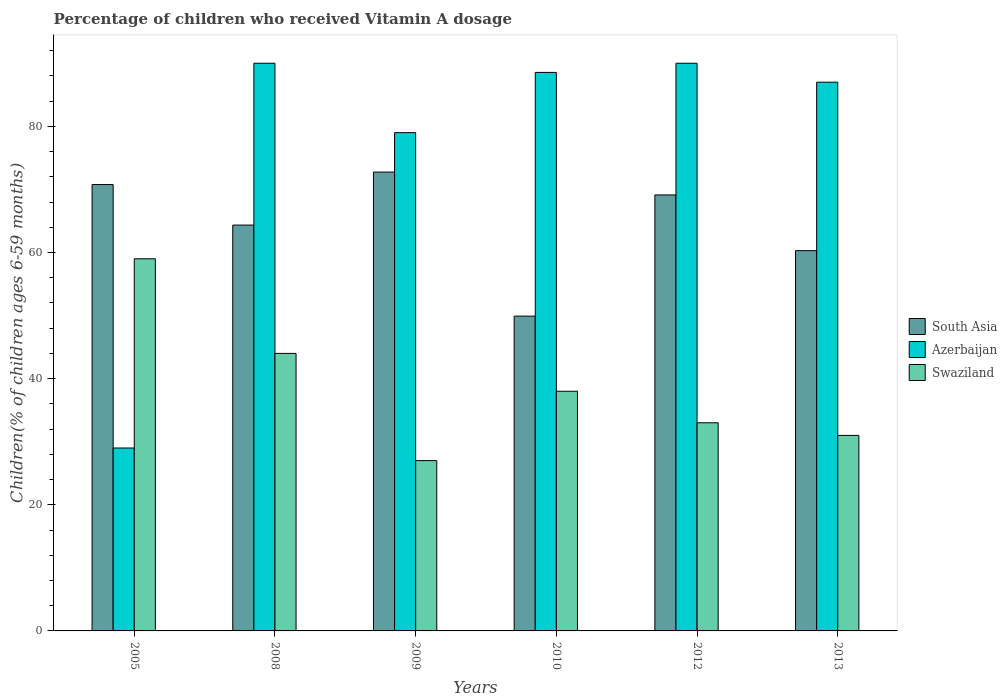How many different coloured bars are there?
Your response must be concise. 3. Are the number of bars per tick equal to the number of legend labels?
Give a very brief answer. Yes. Are the number of bars on each tick of the X-axis equal?
Your response must be concise. Yes. How many bars are there on the 6th tick from the left?
Provide a succinct answer. 3. How many bars are there on the 1st tick from the right?
Keep it short and to the point. 3. What is the label of the 5th group of bars from the left?
Your answer should be very brief. 2012. What is the percentage of children who received Vitamin A dosage in Swaziland in 2005?
Offer a terse response. 59. Across all years, what is the maximum percentage of children who received Vitamin A dosage in South Asia?
Give a very brief answer. 72.75. Across all years, what is the minimum percentage of children who received Vitamin A dosage in Swaziland?
Your answer should be very brief. 27. What is the total percentage of children who received Vitamin A dosage in Swaziland in the graph?
Your answer should be compact. 232. What is the difference between the percentage of children who received Vitamin A dosage in South Asia in 2005 and that in 2013?
Provide a short and direct response. 10.48. What is the difference between the percentage of children who received Vitamin A dosage in South Asia in 2010 and the percentage of children who received Vitamin A dosage in Swaziland in 2009?
Your answer should be compact. 22.91. What is the average percentage of children who received Vitamin A dosage in South Asia per year?
Make the answer very short. 64.53. In the year 2005, what is the difference between the percentage of children who received Vitamin A dosage in South Asia and percentage of children who received Vitamin A dosage in Azerbaijan?
Keep it short and to the point. 41.77. What is the ratio of the percentage of children who received Vitamin A dosage in Swaziland in 2009 to that in 2010?
Your response must be concise. 0.71. What is the difference between the highest and the lowest percentage of children who received Vitamin A dosage in South Asia?
Provide a short and direct response. 22.84. Is the sum of the percentage of children who received Vitamin A dosage in Swaziland in 2005 and 2008 greater than the maximum percentage of children who received Vitamin A dosage in Azerbaijan across all years?
Make the answer very short. Yes. What does the 1st bar from the left in 2009 represents?
Provide a short and direct response. South Asia. What does the 1st bar from the right in 2010 represents?
Your answer should be very brief. Swaziland. Are all the bars in the graph horizontal?
Provide a succinct answer. No. What is the difference between two consecutive major ticks on the Y-axis?
Your answer should be very brief. 20. Are the values on the major ticks of Y-axis written in scientific E-notation?
Give a very brief answer. No. Does the graph contain any zero values?
Provide a short and direct response. No. How many legend labels are there?
Keep it short and to the point. 3. How are the legend labels stacked?
Ensure brevity in your answer.  Vertical. What is the title of the graph?
Make the answer very short. Percentage of children who received Vitamin A dosage. Does "Tajikistan" appear as one of the legend labels in the graph?
Provide a short and direct response. No. What is the label or title of the X-axis?
Offer a terse response. Years. What is the label or title of the Y-axis?
Your answer should be compact. Children(% of children ages 6-59 months). What is the Children(% of children ages 6-59 months) of South Asia in 2005?
Offer a very short reply. 70.77. What is the Children(% of children ages 6-59 months) in Swaziland in 2005?
Your response must be concise. 59. What is the Children(% of children ages 6-59 months) of South Asia in 2008?
Provide a succinct answer. 64.34. What is the Children(% of children ages 6-59 months) of South Asia in 2009?
Provide a short and direct response. 72.75. What is the Children(% of children ages 6-59 months) of Azerbaijan in 2009?
Your answer should be very brief. 79. What is the Children(% of children ages 6-59 months) in Swaziland in 2009?
Give a very brief answer. 27. What is the Children(% of children ages 6-59 months) in South Asia in 2010?
Make the answer very short. 49.91. What is the Children(% of children ages 6-59 months) of Azerbaijan in 2010?
Provide a short and direct response. 88.55. What is the Children(% of children ages 6-59 months) of Swaziland in 2010?
Ensure brevity in your answer.  38. What is the Children(% of children ages 6-59 months) of South Asia in 2012?
Your response must be concise. 69.12. What is the Children(% of children ages 6-59 months) of Azerbaijan in 2012?
Give a very brief answer. 90. What is the Children(% of children ages 6-59 months) in Swaziland in 2012?
Offer a very short reply. 33. What is the Children(% of children ages 6-59 months) in South Asia in 2013?
Give a very brief answer. 60.29. What is the Children(% of children ages 6-59 months) of Azerbaijan in 2013?
Ensure brevity in your answer.  87. What is the Children(% of children ages 6-59 months) in Swaziland in 2013?
Your answer should be very brief. 31. Across all years, what is the maximum Children(% of children ages 6-59 months) in South Asia?
Provide a short and direct response. 72.75. Across all years, what is the maximum Children(% of children ages 6-59 months) in Azerbaijan?
Your response must be concise. 90. Across all years, what is the maximum Children(% of children ages 6-59 months) in Swaziland?
Offer a very short reply. 59. Across all years, what is the minimum Children(% of children ages 6-59 months) of South Asia?
Give a very brief answer. 49.91. Across all years, what is the minimum Children(% of children ages 6-59 months) in Azerbaijan?
Keep it short and to the point. 29. What is the total Children(% of children ages 6-59 months) in South Asia in the graph?
Your response must be concise. 387.19. What is the total Children(% of children ages 6-59 months) of Azerbaijan in the graph?
Offer a terse response. 463.55. What is the total Children(% of children ages 6-59 months) of Swaziland in the graph?
Your answer should be compact. 232. What is the difference between the Children(% of children ages 6-59 months) of South Asia in 2005 and that in 2008?
Provide a succinct answer. 6.43. What is the difference between the Children(% of children ages 6-59 months) of Azerbaijan in 2005 and that in 2008?
Ensure brevity in your answer.  -61. What is the difference between the Children(% of children ages 6-59 months) of Swaziland in 2005 and that in 2008?
Provide a short and direct response. 15. What is the difference between the Children(% of children ages 6-59 months) in South Asia in 2005 and that in 2009?
Make the answer very short. -1.97. What is the difference between the Children(% of children ages 6-59 months) in South Asia in 2005 and that in 2010?
Your answer should be compact. 20.86. What is the difference between the Children(% of children ages 6-59 months) in Azerbaijan in 2005 and that in 2010?
Your answer should be compact. -59.55. What is the difference between the Children(% of children ages 6-59 months) of Swaziland in 2005 and that in 2010?
Give a very brief answer. 21. What is the difference between the Children(% of children ages 6-59 months) of South Asia in 2005 and that in 2012?
Your answer should be compact. 1.65. What is the difference between the Children(% of children ages 6-59 months) of Azerbaijan in 2005 and that in 2012?
Provide a succinct answer. -61. What is the difference between the Children(% of children ages 6-59 months) in South Asia in 2005 and that in 2013?
Keep it short and to the point. 10.48. What is the difference between the Children(% of children ages 6-59 months) of Azerbaijan in 2005 and that in 2013?
Ensure brevity in your answer.  -58. What is the difference between the Children(% of children ages 6-59 months) of South Asia in 2008 and that in 2009?
Ensure brevity in your answer.  -8.4. What is the difference between the Children(% of children ages 6-59 months) in Azerbaijan in 2008 and that in 2009?
Your answer should be compact. 11. What is the difference between the Children(% of children ages 6-59 months) of South Asia in 2008 and that in 2010?
Provide a succinct answer. 14.43. What is the difference between the Children(% of children ages 6-59 months) in Azerbaijan in 2008 and that in 2010?
Give a very brief answer. 1.45. What is the difference between the Children(% of children ages 6-59 months) in Swaziland in 2008 and that in 2010?
Give a very brief answer. 6. What is the difference between the Children(% of children ages 6-59 months) of South Asia in 2008 and that in 2012?
Your answer should be compact. -4.78. What is the difference between the Children(% of children ages 6-59 months) in Swaziland in 2008 and that in 2012?
Provide a succinct answer. 11. What is the difference between the Children(% of children ages 6-59 months) of South Asia in 2008 and that in 2013?
Make the answer very short. 4.05. What is the difference between the Children(% of children ages 6-59 months) of South Asia in 2009 and that in 2010?
Make the answer very short. 22.84. What is the difference between the Children(% of children ages 6-59 months) in Azerbaijan in 2009 and that in 2010?
Offer a terse response. -9.55. What is the difference between the Children(% of children ages 6-59 months) in South Asia in 2009 and that in 2012?
Your answer should be compact. 3.62. What is the difference between the Children(% of children ages 6-59 months) of South Asia in 2009 and that in 2013?
Make the answer very short. 12.45. What is the difference between the Children(% of children ages 6-59 months) in Azerbaijan in 2009 and that in 2013?
Your answer should be compact. -8. What is the difference between the Children(% of children ages 6-59 months) in South Asia in 2010 and that in 2012?
Keep it short and to the point. -19.21. What is the difference between the Children(% of children ages 6-59 months) of Azerbaijan in 2010 and that in 2012?
Give a very brief answer. -1.45. What is the difference between the Children(% of children ages 6-59 months) of Swaziland in 2010 and that in 2012?
Your response must be concise. 5. What is the difference between the Children(% of children ages 6-59 months) of South Asia in 2010 and that in 2013?
Offer a very short reply. -10.38. What is the difference between the Children(% of children ages 6-59 months) of Azerbaijan in 2010 and that in 2013?
Offer a very short reply. 1.55. What is the difference between the Children(% of children ages 6-59 months) in South Asia in 2012 and that in 2013?
Provide a short and direct response. 8.83. What is the difference between the Children(% of children ages 6-59 months) of Azerbaijan in 2012 and that in 2013?
Give a very brief answer. 3. What is the difference between the Children(% of children ages 6-59 months) of Swaziland in 2012 and that in 2013?
Your answer should be compact. 2. What is the difference between the Children(% of children ages 6-59 months) in South Asia in 2005 and the Children(% of children ages 6-59 months) in Azerbaijan in 2008?
Your response must be concise. -19.23. What is the difference between the Children(% of children ages 6-59 months) of South Asia in 2005 and the Children(% of children ages 6-59 months) of Swaziland in 2008?
Your response must be concise. 26.77. What is the difference between the Children(% of children ages 6-59 months) of Azerbaijan in 2005 and the Children(% of children ages 6-59 months) of Swaziland in 2008?
Provide a succinct answer. -15. What is the difference between the Children(% of children ages 6-59 months) in South Asia in 2005 and the Children(% of children ages 6-59 months) in Azerbaijan in 2009?
Offer a very short reply. -8.23. What is the difference between the Children(% of children ages 6-59 months) of South Asia in 2005 and the Children(% of children ages 6-59 months) of Swaziland in 2009?
Provide a short and direct response. 43.77. What is the difference between the Children(% of children ages 6-59 months) of Azerbaijan in 2005 and the Children(% of children ages 6-59 months) of Swaziland in 2009?
Keep it short and to the point. 2. What is the difference between the Children(% of children ages 6-59 months) in South Asia in 2005 and the Children(% of children ages 6-59 months) in Azerbaijan in 2010?
Your answer should be compact. -17.78. What is the difference between the Children(% of children ages 6-59 months) in South Asia in 2005 and the Children(% of children ages 6-59 months) in Swaziland in 2010?
Your response must be concise. 32.77. What is the difference between the Children(% of children ages 6-59 months) of Azerbaijan in 2005 and the Children(% of children ages 6-59 months) of Swaziland in 2010?
Your response must be concise. -9. What is the difference between the Children(% of children ages 6-59 months) in South Asia in 2005 and the Children(% of children ages 6-59 months) in Azerbaijan in 2012?
Give a very brief answer. -19.23. What is the difference between the Children(% of children ages 6-59 months) in South Asia in 2005 and the Children(% of children ages 6-59 months) in Swaziland in 2012?
Your answer should be very brief. 37.77. What is the difference between the Children(% of children ages 6-59 months) of South Asia in 2005 and the Children(% of children ages 6-59 months) of Azerbaijan in 2013?
Your answer should be compact. -16.23. What is the difference between the Children(% of children ages 6-59 months) in South Asia in 2005 and the Children(% of children ages 6-59 months) in Swaziland in 2013?
Offer a terse response. 39.77. What is the difference between the Children(% of children ages 6-59 months) in Azerbaijan in 2005 and the Children(% of children ages 6-59 months) in Swaziland in 2013?
Keep it short and to the point. -2. What is the difference between the Children(% of children ages 6-59 months) of South Asia in 2008 and the Children(% of children ages 6-59 months) of Azerbaijan in 2009?
Make the answer very short. -14.66. What is the difference between the Children(% of children ages 6-59 months) in South Asia in 2008 and the Children(% of children ages 6-59 months) in Swaziland in 2009?
Ensure brevity in your answer.  37.34. What is the difference between the Children(% of children ages 6-59 months) of South Asia in 2008 and the Children(% of children ages 6-59 months) of Azerbaijan in 2010?
Offer a very short reply. -24.21. What is the difference between the Children(% of children ages 6-59 months) of South Asia in 2008 and the Children(% of children ages 6-59 months) of Swaziland in 2010?
Make the answer very short. 26.34. What is the difference between the Children(% of children ages 6-59 months) in South Asia in 2008 and the Children(% of children ages 6-59 months) in Azerbaijan in 2012?
Your answer should be compact. -25.66. What is the difference between the Children(% of children ages 6-59 months) in South Asia in 2008 and the Children(% of children ages 6-59 months) in Swaziland in 2012?
Give a very brief answer. 31.34. What is the difference between the Children(% of children ages 6-59 months) in South Asia in 2008 and the Children(% of children ages 6-59 months) in Azerbaijan in 2013?
Provide a succinct answer. -22.66. What is the difference between the Children(% of children ages 6-59 months) of South Asia in 2008 and the Children(% of children ages 6-59 months) of Swaziland in 2013?
Offer a very short reply. 33.34. What is the difference between the Children(% of children ages 6-59 months) in South Asia in 2009 and the Children(% of children ages 6-59 months) in Azerbaijan in 2010?
Your answer should be compact. -15.8. What is the difference between the Children(% of children ages 6-59 months) in South Asia in 2009 and the Children(% of children ages 6-59 months) in Swaziland in 2010?
Offer a very short reply. 34.75. What is the difference between the Children(% of children ages 6-59 months) in Azerbaijan in 2009 and the Children(% of children ages 6-59 months) in Swaziland in 2010?
Provide a short and direct response. 41. What is the difference between the Children(% of children ages 6-59 months) in South Asia in 2009 and the Children(% of children ages 6-59 months) in Azerbaijan in 2012?
Give a very brief answer. -17.25. What is the difference between the Children(% of children ages 6-59 months) in South Asia in 2009 and the Children(% of children ages 6-59 months) in Swaziland in 2012?
Keep it short and to the point. 39.75. What is the difference between the Children(% of children ages 6-59 months) in Azerbaijan in 2009 and the Children(% of children ages 6-59 months) in Swaziland in 2012?
Your answer should be compact. 46. What is the difference between the Children(% of children ages 6-59 months) of South Asia in 2009 and the Children(% of children ages 6-59 months) of Azerbaijan in 2013?
Provide a succinct answer. -14.25. What is the difference between the Children(% of children ages 6-59 months) of South Asia in 2009 and the Children(% of children ages 6-59 months) of Swaziland in 2013?
Your answer should be compact. 41.75. What is the difference between the Children(% of children ages 6-59 months) of South Asia in 2010 and the Children(% of children ages 6-59 months) of Azerbaijan in 2012?
Give a very brief answer. -40.09. What is the difference between the Children(% of children ages 6-59 months) in South Asia in 2010 and the Children(% of children ages 6-59 months) in Swaziland in 2012?
Your answer should be very brief. 16.91. What is the difference between the Children(% of children ages 6-59 months) in Azerbaijan in 2010 and the Children(% of children ages 6-59 months) in Swaziland in 2012?
Your answer should be compact. 55.55. What is the difference between the Children(% of children ages 6-59 months) of South Asia in 2010 and the Children(% of children ages 6-59 months) of Azerbaijan in 2013?
Your answer should be compact. -37.09. What is the difference between the Children(% of children ages 6-59 months) in South Asia in 2010 and the Children(% of children ages 6-59 months) in Swaziland in 2013?
Your answer should be very brief. 18.91. What is the difference between the Children(% of children ages 6-59 months) of Azerbaijan in 2010 and the Children(% of children ages 6-59 months) of Swaziland in 2013?
Your answer should be very brief. 57.55. What is the difference between the Children(% of children ages 6-59 months) of South Asia in 2012 and the Children(% of children ages 6-59 months) of Azerbaijan in 2013?
Keep it short and to the point. -17.88. What is the difference between the Children(% of children ages 6-59 months) in South Asia in 2012 and the Children(% of children ages 6-59 months) in Swaziland in 2013?
Your answer should be very brief. 38.12. What is the average Children(% of children ages 6-59 months) of South Asia per year?
Offer a very short reply. 64.53. What is the average Children(% of children ages 6-59 months) of Azerbaijan per year?
Give a very brief answer. 77.26. What is the average Children(% of children ages 6-59 months) of Swaziland per year?
Offer a terse response. 38.67. In the year 2005, what is the difference between the Children(% of children ages 6-59 months) of South Asia and Children(% of children ages 6-59 months) of Azerbaijan?
Give a very brief answer. 41.77. In the year 2005, what is the difference between the Children(% of children ages 6-59 months) in South Asia and Children(% of children ages 6-59 months) in Swaziland?
Give a very brief answer. 11.77. In the year 2005, what is the difference between the Children(% of children ages 6-59 months) in Azerbaijan and Children(% of children ages 6-59 months) in Swaziland?
Provide a short and direct response. -30. In the year 2008, what is the difference between the Children(% of children ages 6-59 months) of South Asia and Children(% of children ages 6-59 months) of Azerbaijan?
Give a very brief answer. -25.66. In the year 2008, what is the difference between the Children(% of children ages 6-59 months) in South Asia and Children(% of children ages 6-59 months) in Swaziland?
Your response must be concise. 20.34. In the year 2009, what is the difference between the Children(% of children ages 6-59 months) of South Asia and Children(% of children ages 6-59 months) of Azerbaijan?
Make the answer very short. -6.25. In the year 2009, what is the difference between the Children(% of children ages 6-59 months) of South Asia and Children(% of children ages 6-59 months) of Swaziland?
Offer a terse response. 45.75. In the year 2009, what is the difference between the Children(% of children ages 6-59 months) of Azerbaijan and Children(% of children ages 6-59 months) of Swaziland?
Offer a terse response. 52. In the year 2010, what is the difference between the Children(% of children ages 6-59 months) in South Asia and Children(% of children ages 6-59 months) in Azerbaijan?
Provide a succinct answer. -38.64. In the year 2010, what is the difference between the Children(% of children ages 6-59 months) in South Asia and Children(% of children ages 6-59 months) in Swaziland?
Your answer should be compact. 11.91. In the year 2010, what is the difference between the Children(% of children ages 6-59 months) in Azerbaijan and Children(% of children ages 6-59 months) in Swaziland?
Offer a very short reply. 50.55. In the year 2012, what is the difference between the Children(% of children ages 6-59 months) of South Asia and Children(% of children ages 6-59 months) of Azerbaijan?
Your answer should be very brief. -20.88. In the year 2012, what is the difference between the Children(% of children ages 6-59 months) of South Asia and Children(% of children ages 6-59 months) of Swaziland?
Your response must be concise. 36.12. In the year 2013, what is the difference between the Children(% of children ages 6-59 months) of South Asia and Children(% of children ages 6-59 months) of Azerbaijan?
Keep it short and to the point. -26.71. In the year 2013, what is the difference between the Children(% of children ages 6-59 months) of South Asia and Children(% of children ages 6-59 months) of Swaziland?
Provide a short and direct response. 29.29. In the year 2013, what is the difference between the Children(% of children ages 6-59 months) in Azerbaijan and Children(% of children ages 6-59 months) in Swaziland?
Make the answer very short. 56. What is the ratio of the Children(% of children ages 6-59 months) of South Asia in 2005 to that in 2008?
Offer a very short reply. 1.1. What is the ratio of the Children(% of children ages 6-59 months) of Azerbaijan in 2005 to that in 2008?
Offer a terse response. 0.32. What is the ratio of the Children(% of children ages 6-59 months) of Swaziland in 2005 to that in 2008?
Your response must be concise. 1.34. What is the ratio of the Children(% of children ages 6-59 months) of South Asia in 2005 to that in 2009?
Keep it short and to the point. 0.97. What is the ratio of the Children(% of children ages 6-59 months) of Azerbaijan in 2005 to that in 2009?
Ensure brevity in your answer.  0.37. What is the ratio of the Children(% of children ages 6-59 months) of Swaziland in 2005 to that in 2009?
Offer a terse response. 2.19. What is the ratio of the Children(% of children ages 6-59 months) of South Asia in 2005 to that in 2010?
Offer a very short reply. 1.42. What is the ratio of the Children(% of children ages 6-59 months) in Azerbaijan in 2005 to that in 2010?
Ensure brevity in your answer.  0.33. What is the ratio of the Children(% of children ages 6-59 months) in Swaziland in 2005 to that in 2010?
Provide a short and direct response. 1.55. What is the ratio of the Children(% of children ages 6-59 months) of South Asia in 2005 to that in 2012?
Your response must be concise. 1.02. What is the ratio of the Children(% of children ages 6-59 months) of Azerbaijan in 2005 to that in 2012?
Keep it short and to the point. 0.32. What is the ratio of the Children(% of children ages 6-59 months) of Swaziland in 2005 to that in 2012?
Make the answer very short. 1.79. What is the ratio of the Children(% of children ages 6-59 months) of South Asia in 2005 to that in 2013?
Ensure brevity in your answer.  1.17. What is the ratio of the Children(% of children ages 6-59 months) of Azerbaijan in 2005 to that in 2013?
Provide a short and direct response. 0.33. What is the ratio of the Children(% of children ages 6-59 months) in Swaziland in 2005 to that in 2013?
Your answer should be very brief. 1.9. What is the ratio of the Children(% of children ages 6-59 months) in South Asia in 2008 to that in 2009?
Ensure brevity in your answer.  0.88. What is the ratio of the Children(% of children ages 6-59 months) of Azerbaijan in 2008 to that in 2009?
Offer a very short reply. 1.14. What is the ratio of the Children(% of children ages 6-59 months) of Swaziland in 2008 to that in 2009?
Your answer should be compact. 1.63. What is the ratio of the Children(% of children ages 6-59 months) in South Asia in 2008 to that in 2010?
Give a very brief answer. 1.29. What is the ratio of the Children(% of children ages 6-59 months) in Azerbaijan in 2008 to that in 2010?
Your response must be concise. 1.02. What is the ratio of the Children(% of children ages 6-59 months) in Swaziland in 2008 to that in 2010?
Provide a short and direct response. 1.16. What is the ratio of the Children(% of children ages 6-59 months) of South Asia in 2008 to that in 2012?
Offer a very short reply. 0.93. What is the ratio of the Children(% of children ages 6-59 months) of Azerbaijan in 2008 to that in 2012?
Your answer should be very brief. 1. What is the ratio of the Children(% of children ages 6-59 months) of South Asia in 2008 to that in 2013?
Your response must be concise. 1.07. What is the ratio of the Children(% of children ages 6-59 months) in Azerbaijan in 2008 to that in 2013?
Your answer should be compact. 1.03. What is the ratio of the Children(% of children ages 6-59 months) of Swaziland in 2008 to that in 2013?
Provide a succinct answer. 1.42. What is the ratio of the Children(% of children ages 6-59 months) of South Asia in 2009 to that in 2010?
Provide a short and direct response. 1.46. What is the ratio of the Children(% of children ages 6-59 months) in Azerbaijan in 2009 to that in 2010?
Provide a short and direct response. 0.89. What is the ratio of the Children(% of children ages 6-59 months) in Swaziland in 2009 to that in 2010?
Your response must be concise. 0.71. What is the ratio of the Children(% of children ages 6-59 months) of South Asia in 2009 to that in 2012?
Ensure brevity in your answer.  1.05. What is the ratio of the Children(% of children ages 6-59 months) in Azerbaijan in 2009 to that in 2012?
Provide a short and direct response. 0.88. What is the ratio of the Children(% of children ages 6-59 months) in Swaziland in 2009 to that in 2012?
Make the answer very short. 0.82. What is the ratio of the Children(% of children ages 6-59 months) in South Asia in 2009 to that in 2013?
Make the answer very short. 1.21. What is the ratio of the Children(% of children ages 6-59 months) in Azerbaijan in 2009 to that in 2013?
Your answer should be very brief. 0.91. What is the ratio of the Children(% of children ages 6-59 months) in Swaziland in 2009 to that in 2013?
Give a very brief answer. 0.87. What is the ratio of the Children(% of children ages 6-59 months) in South Asia in 2010 to that in 2012?
Provide a short and direct response. 0.72. What is the ratio of the Children(% of children ages 6-59 months) in Azerbaijan in 2010 to that in 2012?
Your answer should be compact. 0.98. What is the ratio of the Children(% of children ages 6-59 months) of Swaziland in 2010 to that in 2012?
Ensure brevity in your answer.  1.15. What is the ratio of the Children(% of children ages 6-59 months) in South Asia in 2010 to that in 2013?
Keep it short and to the point. 0.83. What is the ratio of the Children(% of children ages 6-59 months) in Azerbaijan in 2010 to that in 2013?
Offer a very short reply. 1.02. What is the ratio of the Children(% of children ages 6-59 months) in Swaziland in 2010 to that in 2013?
Give a very brief answer. 1.23. What is the ratio of the Children(% of children ages 6-59 months) of South Asia in 2012 to that in 2013?
Offer a terse response. 1.15. What is the ratio of the Children(% of children ages 6-59 months) in Azerbaijan in 2012 to that in 2013?
Ensure brevity in your answer.  1.03. What is the ratio of the Children(% of children ages 6-59 months) in Swaziland in 2012 to that in 2013?
Offer a very short reply. 1.06. What is the difference between the highest and the second highest Children(% of children ages 6-59 months) of South Asia?
Your response must be concise. 1.97. What is the difference between the highest and the second highest Children(% of children ages 6-59 months) in Azerbaijan?
Your answer should be very brief. 0. What is the difference between the highest and the second highest Children(% of children ages 6-59 months) in Swaziland?
Make the answer very short. 15. What is the difference between the highest and the lowest Children(% of children ages 6-59 months) in South Asia?
Offer a very short reply. 22.84. What is the difference between the highest and the lowest Children(% of children ages 6-59 months) of Azerbaijan?
Provide a succinct answer. 61. 